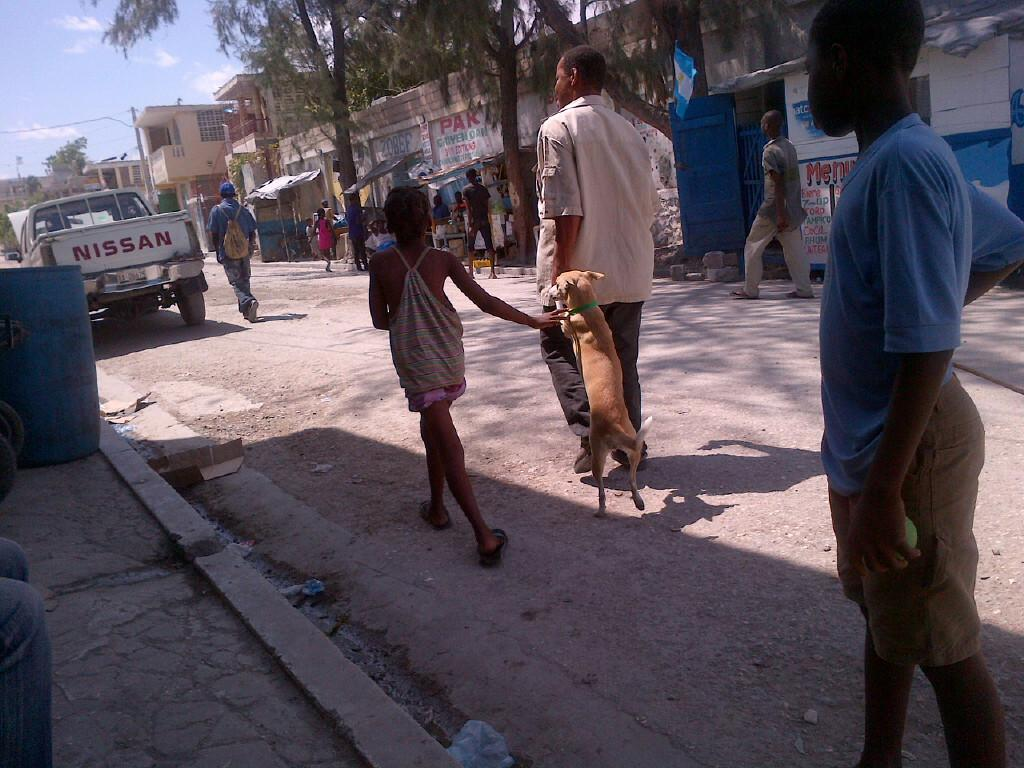How many people are in the group visible in the image? There is a group of people in the image. What are the people in the group doing? The people are walking on the road. Is there any animal accompanying the group of people? Yes, there is a dog with the group of people. What can be seen in the background of the image? There are trees and buildings visible in the image. What else can be seen in the image? There is a vehicle in the image. What type of meal is being prepared in the middle of the image? There is no meal preparation visible in the image; it features a group of people walking on the road with a dog. What is the head of the dog doing in the image? There is no specific action of the dog's head mentioned in the image; it is simply walking with the group of people. 